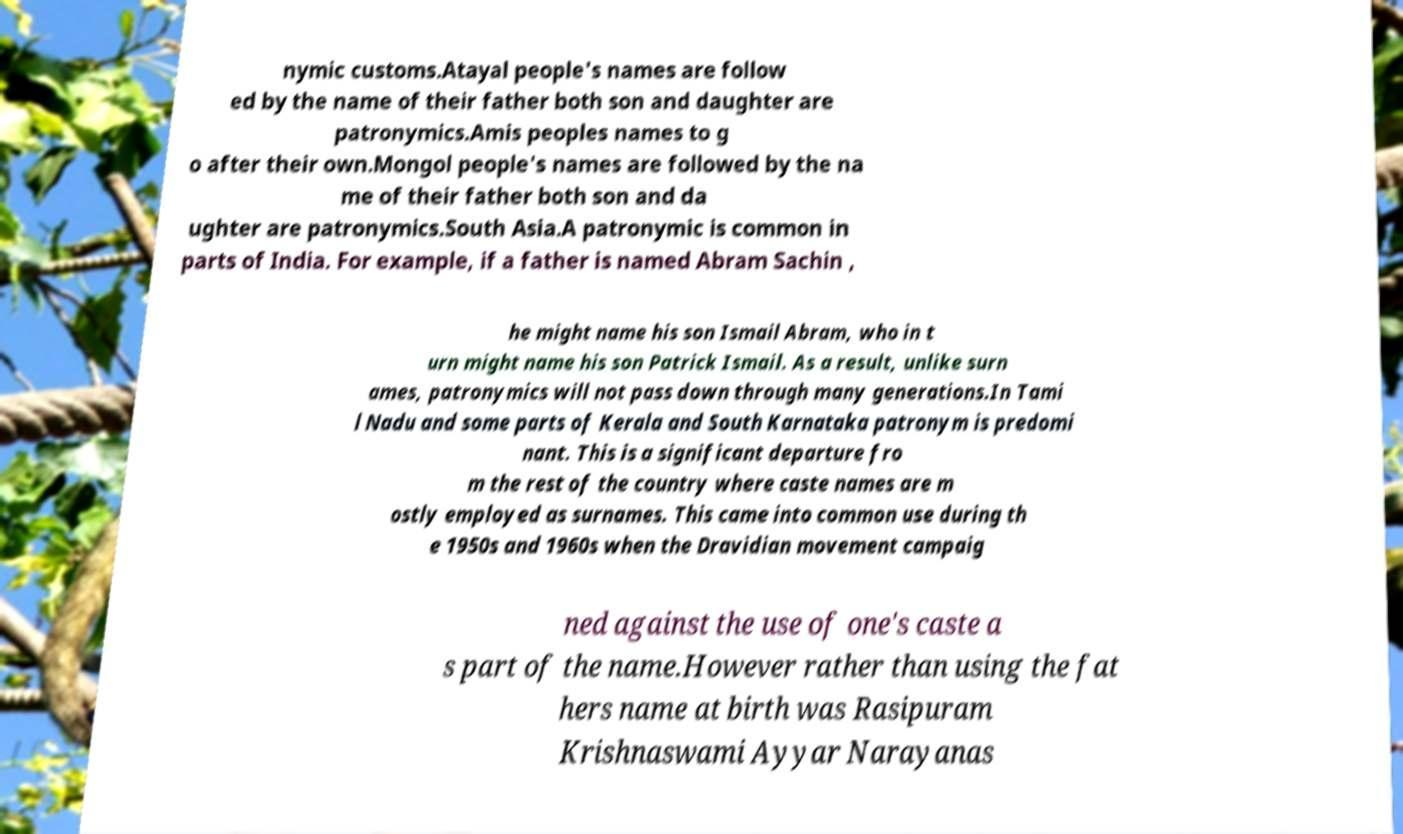What messages or text are displayed in this image? I need them in a readable, typed format. nymic customs.Atayal people's names are follow ed by the name of their father both son and daughter are patronymics.Amis peoples names to g o after their own.Mongol people's names are followed by the na me of their father both son and da ughter are patronymics.South Asia.A patronymic is common in parts of India. For example, if a father is named Abram Sachin , he might name his son Ismail Abram, who in t urn might name his son Patrick Ismail. As a result, unlike surn ames, patronymics will not pass down through many generations.In Tami l Nadu and some parts of Kerala and South Karnataka patronym is predomi nant. This is a significant departure fro m the rest of the country where caste names are m ostly employed as surnames. This came into common use during th e 1950s and 1960s when the Dravidian movement campaig ned against the use of one's caste a s part of the name.However rather than using the fat hers name at birth was Rasipuram Krishnaswami Ayyar Narayanas 